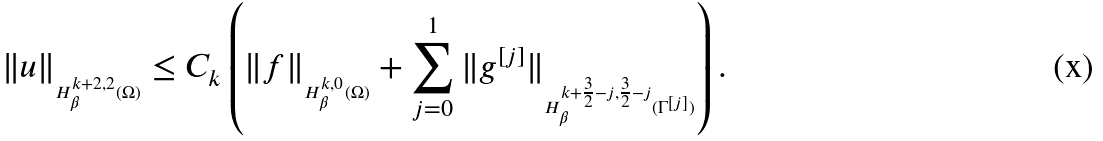<formula> <loc_0><loc_0><loc_500><loc_500>\| u \| _ { _ { H _ { \beta } ^ { k + 2 , 2 } ( \Omega ) } } \leq C _ { k } \left ( \| f \| _ { _ { H _ { \beta } ^ { k , 0 } ( \Omega ) } } + \sum _ { j = 0 } ^ { 1 } \| g ^ { [ j ] } \| _ { _ { H _ { \beta } ^ { k + \frac { 3 } { 2 } - j , \frac { 3 } { 2 } - j } ( \Gamma ^ { [ j ] } ) } } \right ) .</formula> 